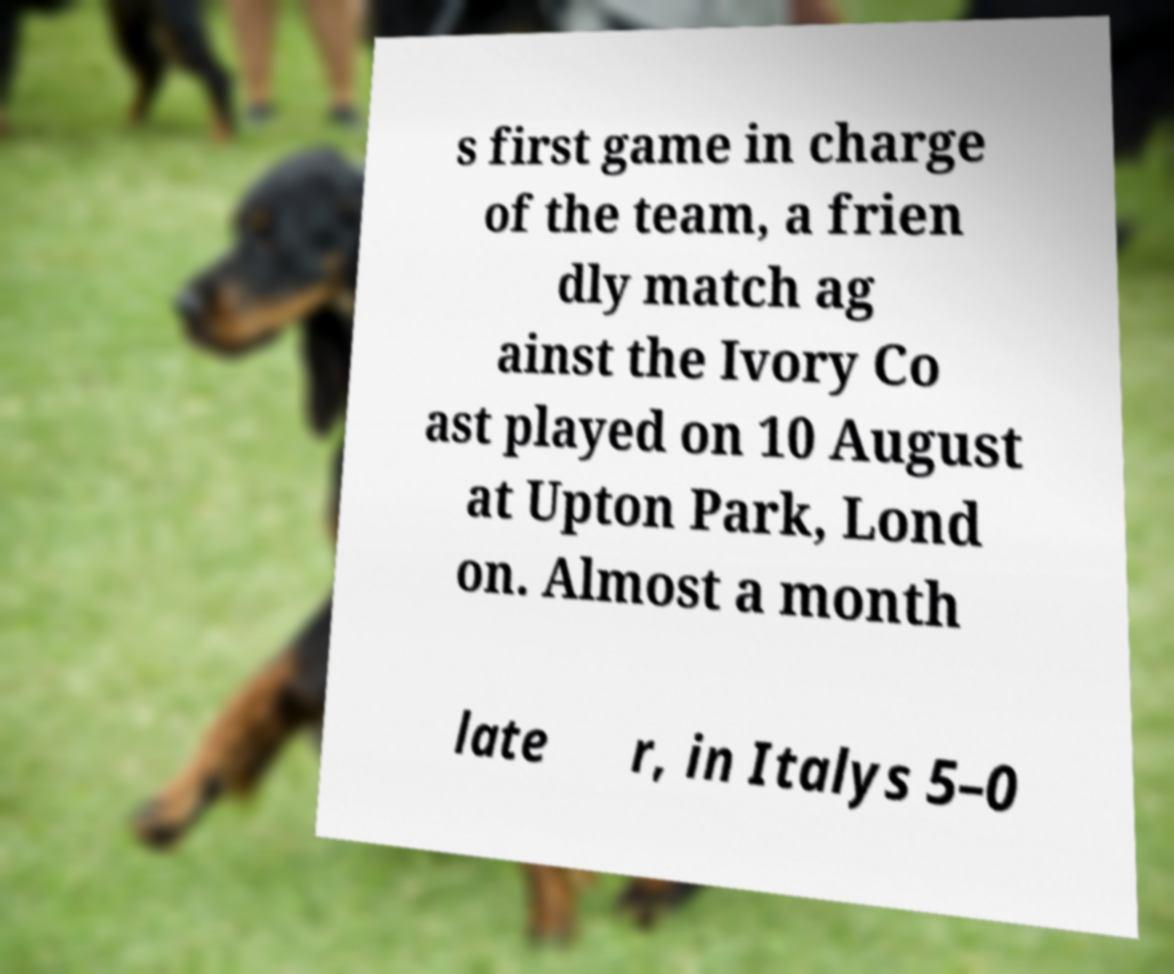Could you extract and type out the text from this image? s first game in charge of the team, a frien dly match ag ainst the Ivory Co ast played on 10 August at Upton Park, Lond on. Almost a month late r, in Italys 5–0 